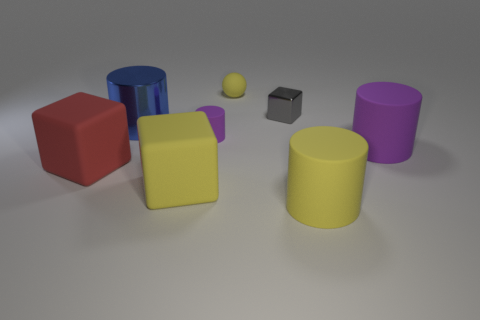Add 1 tiny green metallic things. How many objects exist? 9 Subtract all spheres. How many objects are left? 7 Subtract all yellow things. Subtract all blue cylinders. How many objects are left? 4 Add 1 purple cylinders. How many purple cylinders are left? 3 Add 5 red rubber cubes. How many red rubber cubes exist? 6 Subtract 1 purple cylinders. How many objects are left? 7 